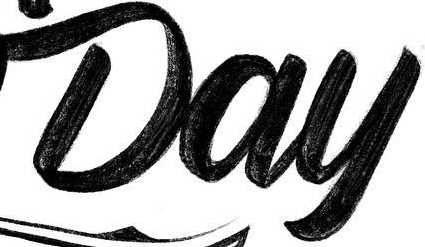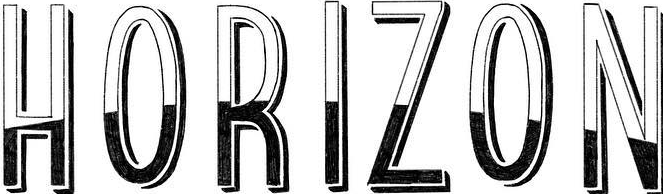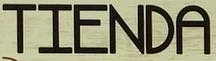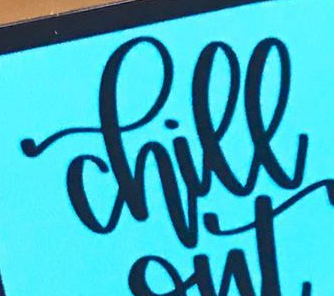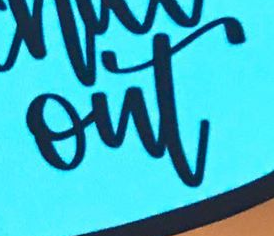What text is displayed in these images sequentially, separated by a semicolon? Day; HORIZON; TIENDA; chill; out 